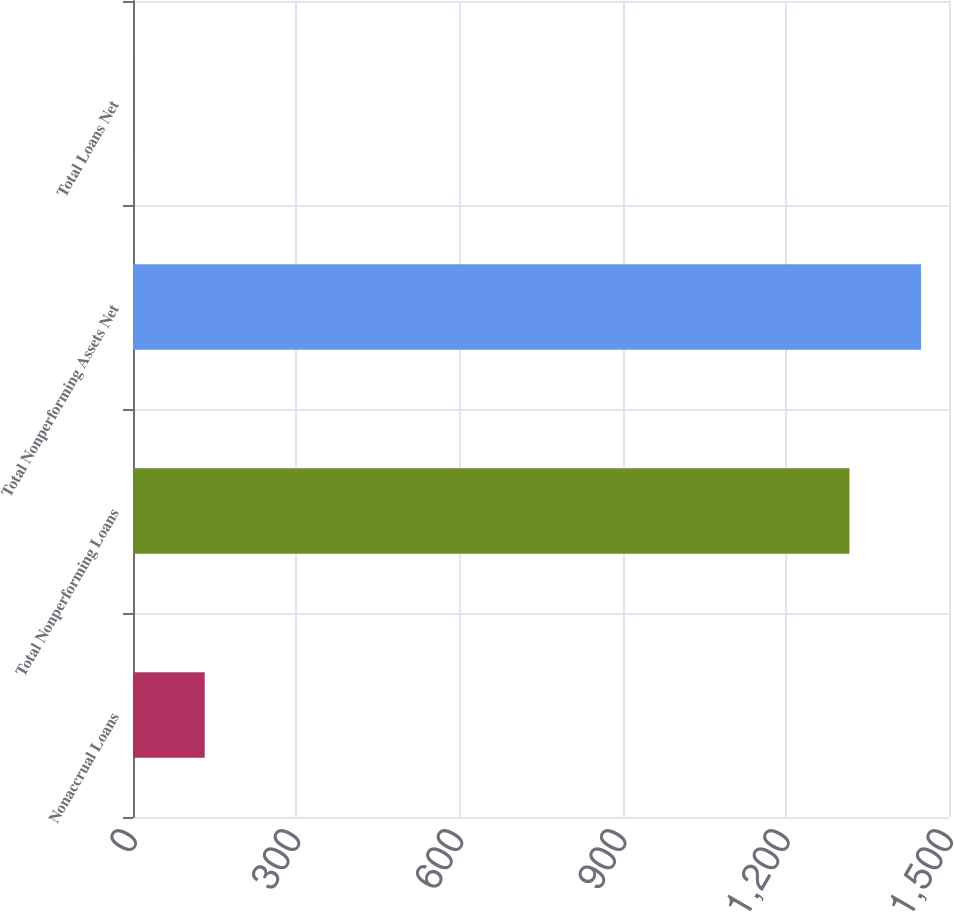Convert chart. <chart><loc_0><loc_0><loc_500><loc_500><bar_chart><fcel>Nonaccrual Loans<fcel>Total Nonperforming Loans<fcel>Total Nonperforming Assets Net<fcel>Total Loans Net<nl><fcel>131.82<fcel>1317<fcel>1448.69<fcel>0.13<nl></chart> 